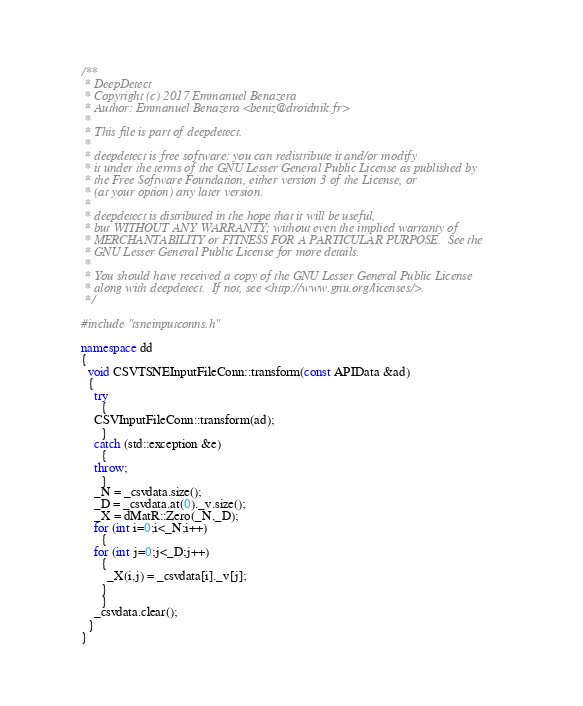Convert code to text. <code><loc_0><loc_0><loc_500><loc_500><_C++_>/**
 * DeepDetect
 * Copyright (c) 2017 Emmanuel Benazera
 * Author: Emmanuel Benazera <beniz@droidnik.fr>
 *
 * This file is part of deepdetect.
 *
 * deepdetect is free software: you can redistribute it and/or modify
 * it under the terms of the GNU Lesser General Public License as published by
 * the Free Software Foundation, either version 3 of the License, or
 * (at your option) any later version.
 *
 * deepdetect is distributed in the hope that it will be useful,
 * but WITHOUT ANY WARRANTY; without even the implied warranty of
 * MERCHANTABILITY or FITNESS FOR A PARTICULAR PURPOSE.  See the
 * GNU Lesser General Public License for more details.
 *
 * You should have received a copy of the GNU Lesser General Public License
 * along with deepdetect.  If not, see <http://www.gnu.org/licenses/>.
 */

#include "tsneinputconns.h"

namespace dd
{
  void CSVTSNEInputFileConn::transform(const APIData &ad)
  {
    try
      {
	CSVInputFileConn::transform(ad);
      }
    catch (std::exception &e)
      {
	throw;
      }
    _N = _csvdata.size();
    _D = _csvdata.at(0)._v.size();
    _X = dMatR::Zero(_N,_D);
    for (int i=0;i<_N;i++)
      {
	for (int j=0;j<_D;j++)
	  {
	    _X(i,j) = _csvdata[i]._v[j];
	  }
      }
    _csvdata.clear();
  }
}
</code> 